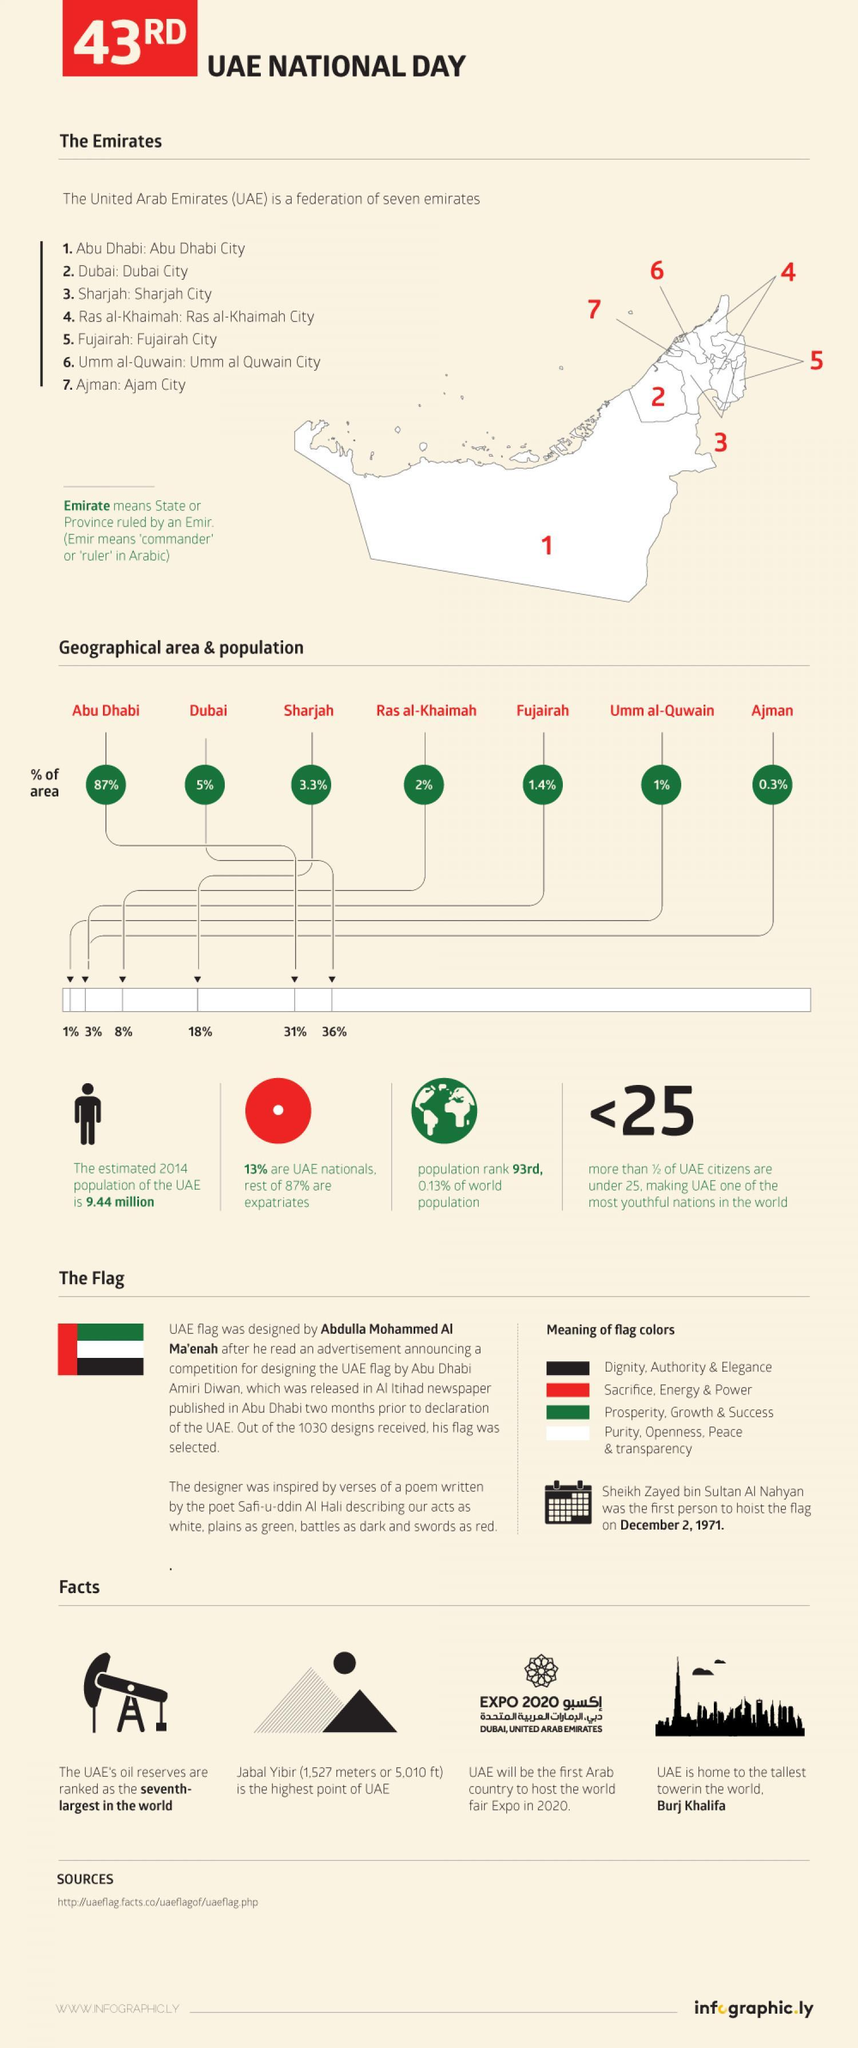Which is the tallest building in the world?
Answer the question with a short phrase. Burj Khalifa What percentage of total United Arab Emirates population is in Dubai? 36% Which is the smallest emirate in UAE? Ajman City What percentage of total United Arab Emirates population is in Fujairah? 3% Which is the most populated emirate in UAE? Dubai City Which is the largest emirate in UAE by area? Abu Dhabi Which is the fourth largest emirate in UAE? Ras al-Khaimah Which is the second largest emirate in UAE? Dubai City What percent of the total area of the UAE is covered by Sharjah City? 3.3% 